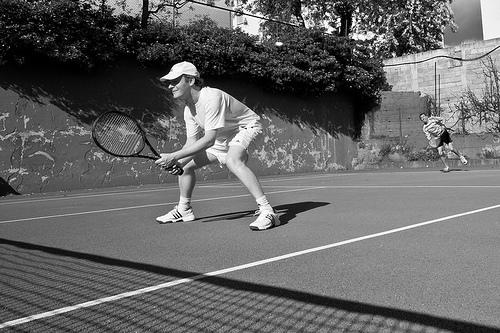Illustrate the picture focusing on the court's environment, including plants and architecture. A tennis game unfolds on a serene court with an encompassing cement wall and bushes that contribute to the court's elegant appearance. Illustrate the key components in the image with a focus on the attire worn by the subjects. Athletic tennis players dressed in shorts, shirts, hats, socks, and sneakers engage in a match on a tennis court. Represent the primary scenario in the picture using a concise sentence. A man is playing tennis on a court while his teammate watches from the background. Write a description of the scene with an emphasis on the backdrop. On a well-maintained tennis court surrounded by bushes and a cement wall, two players exhibit their tennis skills using high-quality rackets. Describe the picture while emphasizing the teamwork shown by the tennis players. Two well-dressed teammates cooperate and give their best effort as they engage in a friendly tennis match on a beautiful court. Create a brief narrative about what is happening in the artwork. Two energized tennis players are immersed in an intense match, with one player masterfully wielding his black racket to strike the ball. Elaborate on the scenario portrayed in the photo, emphasizing the primary participant and his equipment. A skilled tennis player in a white cap, striped shirt, and athletic shorts grips his black racket firmly, focusing his attention on the game. Concisely describe the main activity taking place and mention the shadows present in the picture. A man plays tennis on a court with the shadows of a tennis net and players cast on the ground. Craft a sentence mentioning the primary tennis player and his clothing in the image. A focused tennis player dressed in a white shirt, shorts, hat, socks, and sneakers holds a black racket as he readies for the next shot. Write a summary of the photograph, focusing on the tennis court and its surrounding features. Two players compete on a tennis court with white lines, encompassed by a cement wall, bushes, and a net casting a long shadow. 